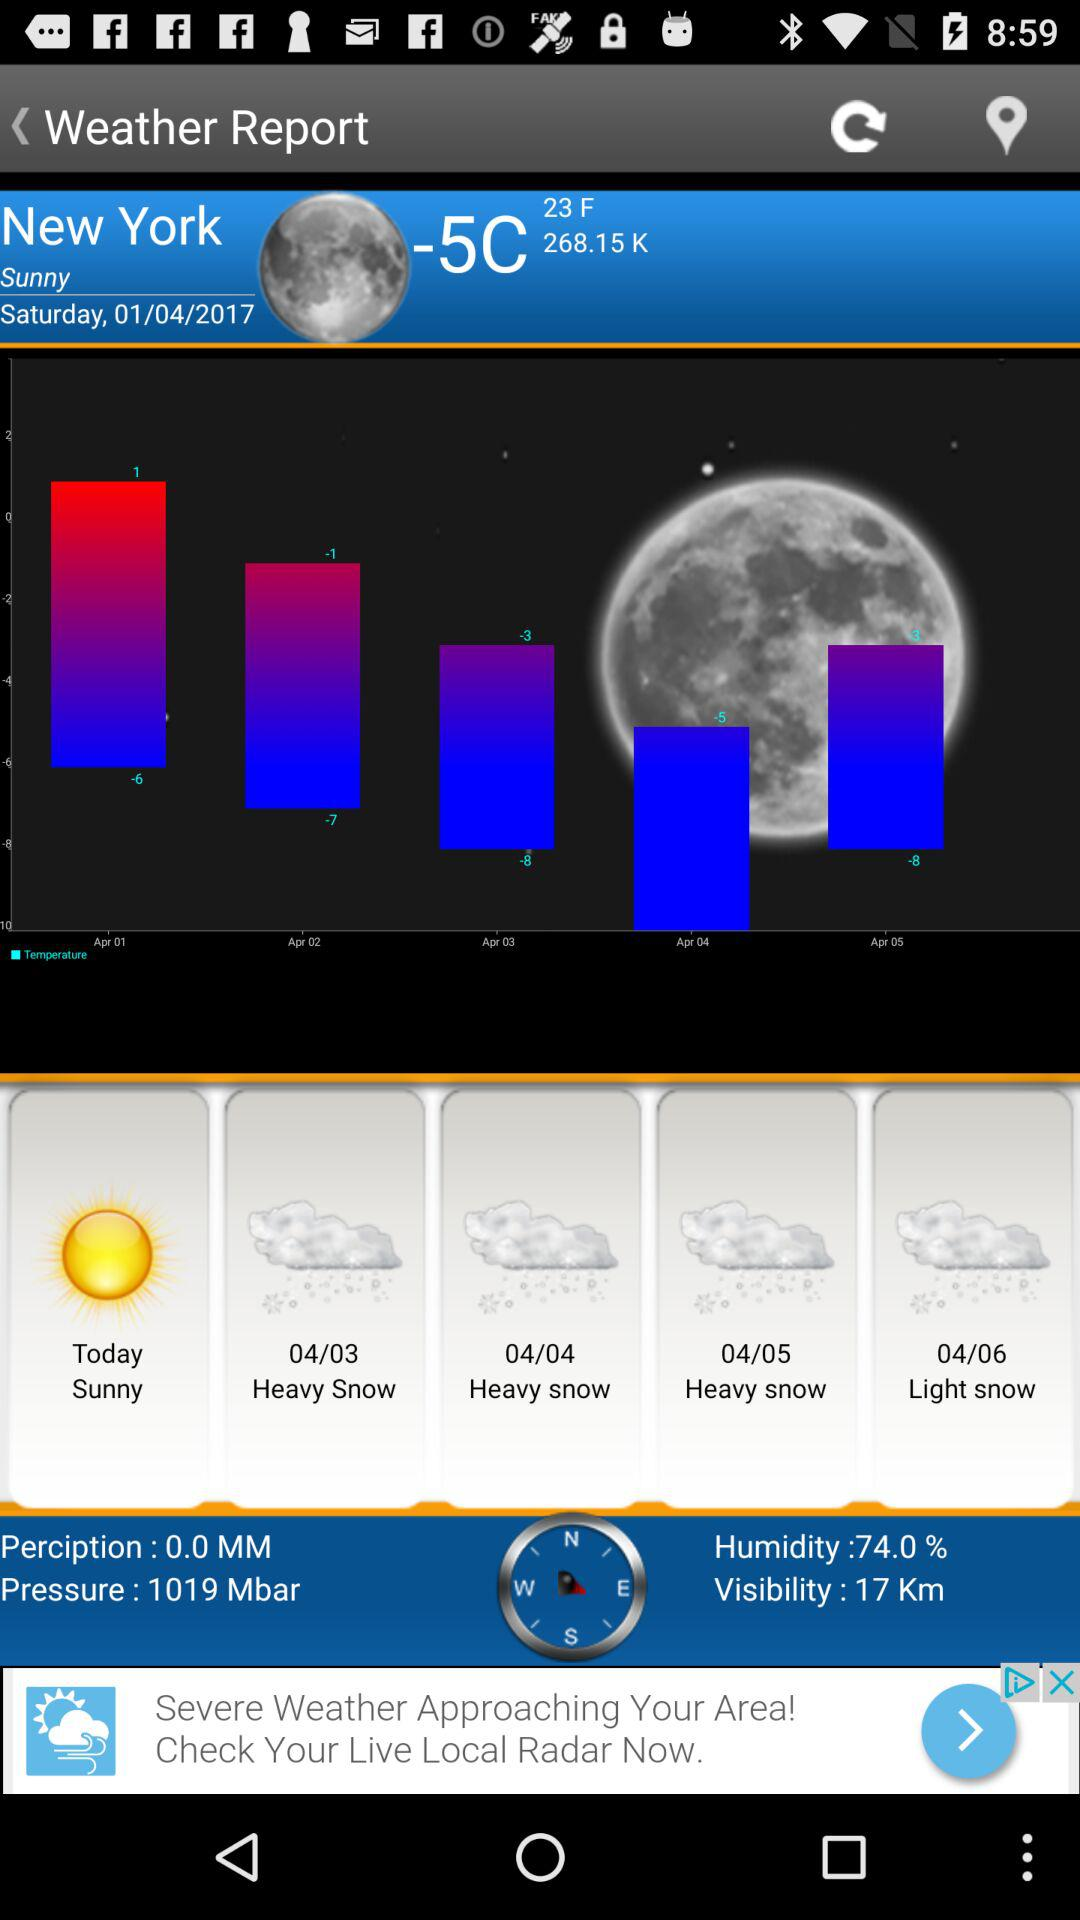What is the humidity percentage? The humidity is 74%. 